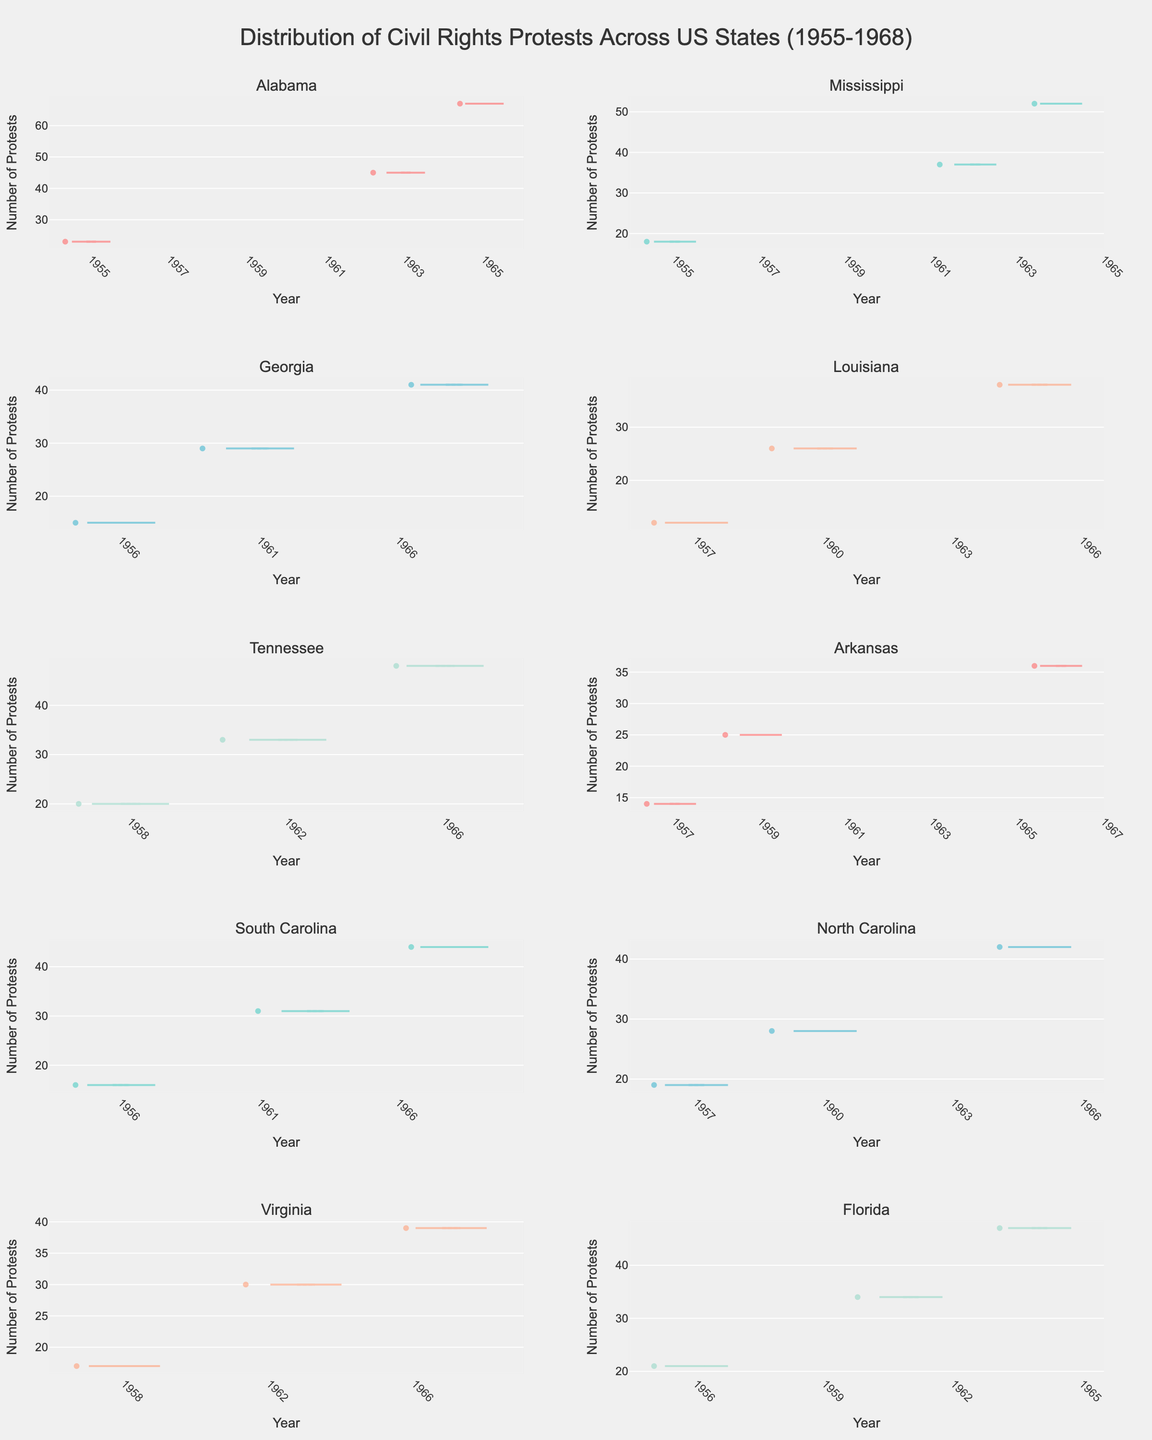Which state had the highest number of protests in 1965? By looking at the plot for each state, you compare the number of protests in the year 1965 across states. Alabama had the highest number of protests in 1965, with 67 protests.
Answer: Alabama How many protests were there in Florida in 1961? Identify the density plot corresponding to Florida and locate the year 1961 on the x-axis. By referring to the corresponding point, Florida had 34 protests in 1961.
Answer: 34 Which state had the least number of protests in any recorded year? Compare the lowest points on the y-axis of each state's density plot to find the state with the minimum number of protests. Louisiana had the least number of protests in 1957, with 12 protests.
Answer: Louisiana How does the number of protests in Alabama in 1963 compare to that in Mississippi in 1962? From the plots, Alabama had 45 protests in 1963, while Mississippi had 37 protests in 1962. Therefore, Alabama had more protests in 1963 than Mississippi had in 1962.
Answer: Alabama had more What is the overall trend in the number of protests in South Carolina from 1956 to 1968? By observing the density plot for South Carolina, note the increasing numbers of protests from 1956 (16 protests) to 1968 (44 protests). The trend shows a gradual increase in the number of protests over the years.
Answer: Increasing What is the average number of protests in Georgia across the recorded years? The number of protests in Georgia are 15, 29, and 41 for the years 1956, 1961, and 1968, respectively. Calculate the average by summing these values and dividing by 3. (15 + 29 + 41) / 3 = 28.33
Answer: 28.33 In which year did North Carolina see the highest number of protests? Refer to North Carolina's subplot and identify the year on the x-axis with the highest corresponding point on the y-axis. North Carolina saw the highest number of protests in 1965, with 42 protests.
Answer: 1965 Between Arkansas and Tennessee, which state had more protests in 1966? Observe the density plots for Arkansas and Tennessee for the year 1966. Arkansas had 36 protests, while Tennessee had 48 protests in 1966. Therefore, Tennessee had more protests.
Answer: Tennessee Which state had a significant increase in protests between two consecutive recorded years, and what were those years? By analyzing each subplot, identify states where there is a notable jump in the number of protests between two consecutive data points. Alabama had a significant increase from 1955 (23 protests) to 1963 (45 protests).
Answer: Alabama, 1955 to 1963 